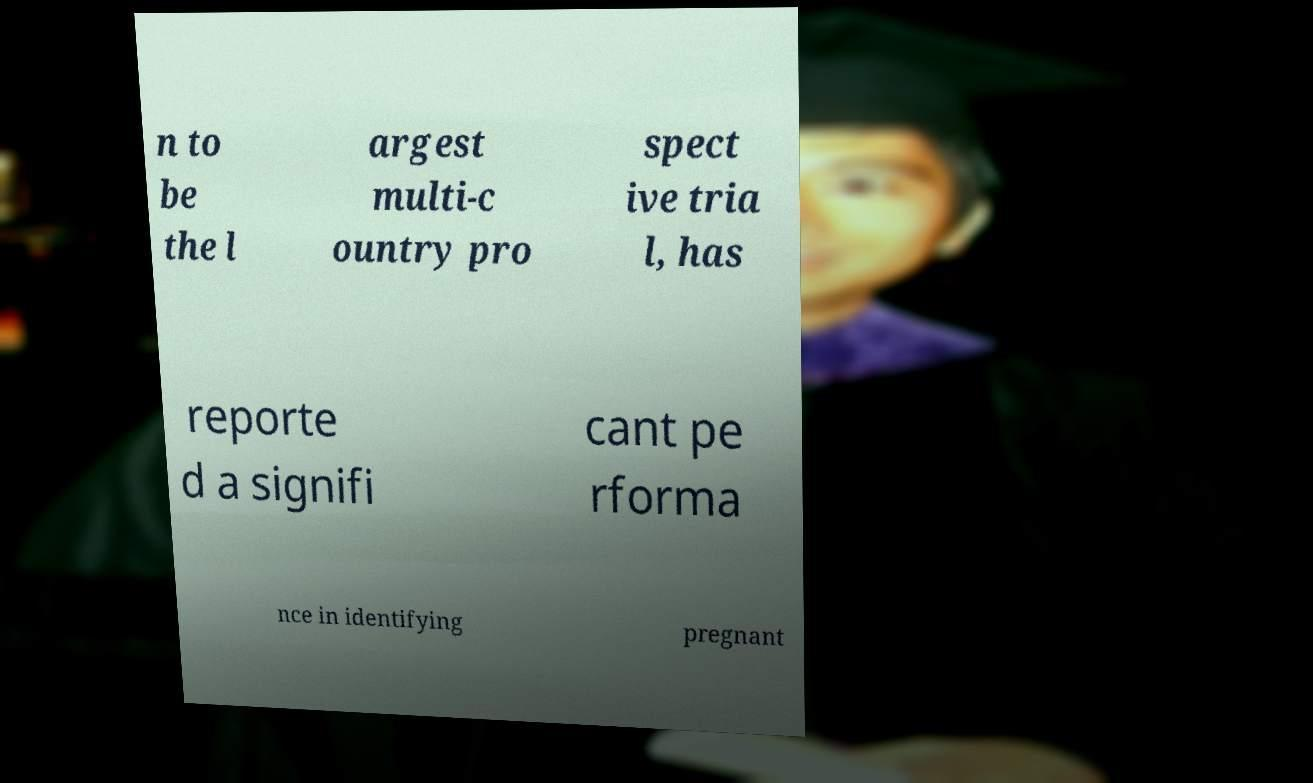Can you read and provide the text displayed in the image?This photo seems to have some interesting text. Can you extract and type it out for me? n to be the l argest multi-c ountry pro spect ive tria l, has reporte d a signifi cant pe rforma nce in identifying pregnant 